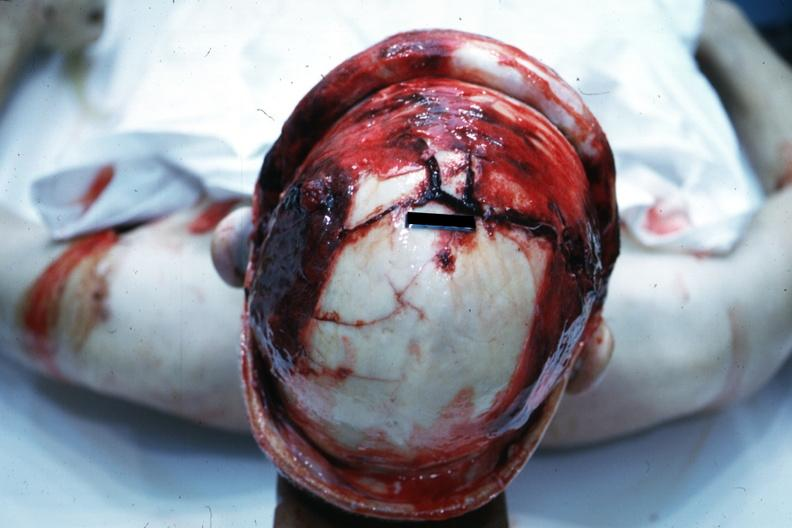s bone, calvarium present?
Answer the question using a single word or phrase. Yes 